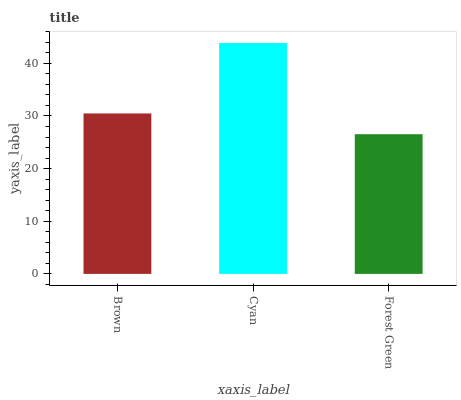Is Forest Green the minimum?
Answer yes or no. Yes. Is Cyan the maximum?
Answer yes or no. Yes. Is Cyan the minimum?
Answer yes or no. No. Is Forest Green the maximum?
Answer yes or no. No. Is Cyan greater than Forest Green?
Answer yes or no. Yes. Is Forest Green less than Cyan?
Answer yes or no. Yes. Is Forest Green greater than Cyan?
Answer yes or no. No. Is Cyan less than Forest Green?
Answer yes or no. No. Is Brown the high median?
Answer yes or no. Yes. Is Brown the low median?
Answer yes or no. Yes. Is Cyan the high median?
Answer yes or no. No. Is Forest Green the low median?
Answer yes or no. No. 